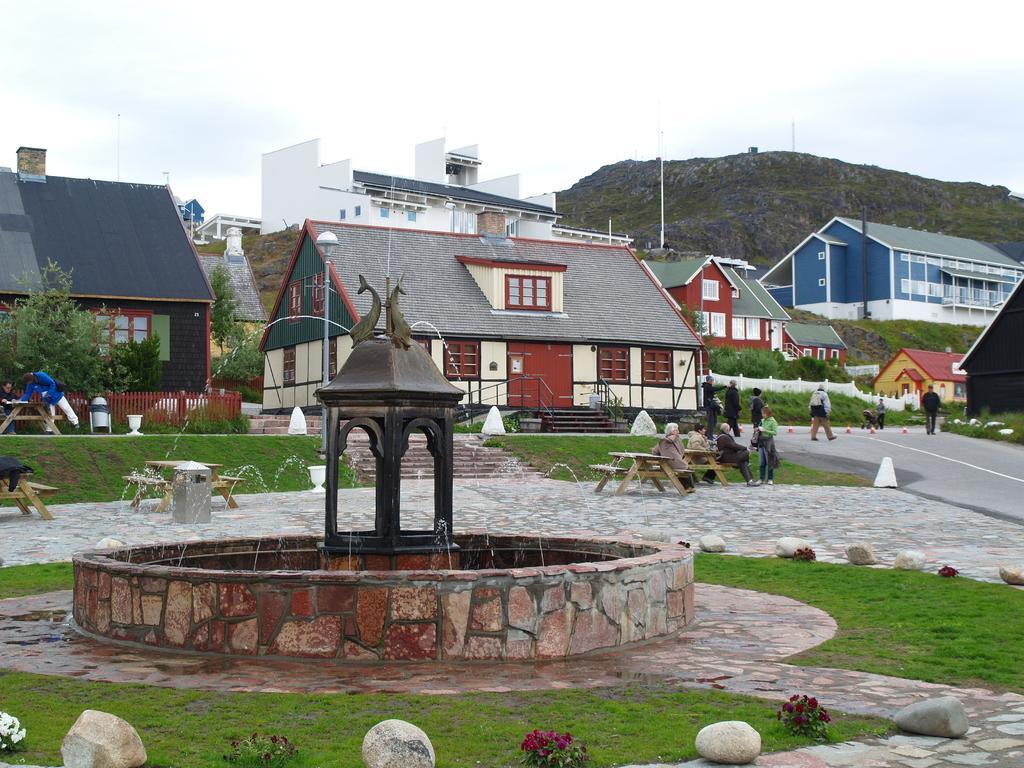Could you give a brief overview of what you see in this image? Here there are houses, where there are people on the road, this is water and a sky. 